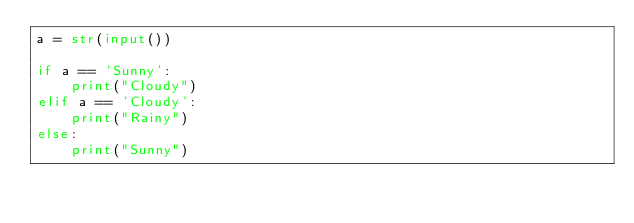Convert code to text. <code><loc_0><loc_0><loc_500><loc_500><_Python_>a = str(input())

if a == 'Sunny':
    print("Cloudy")
elif a == 'Cloudy':
    print("Rainy")
else:
    print("Sunny")


</code> 